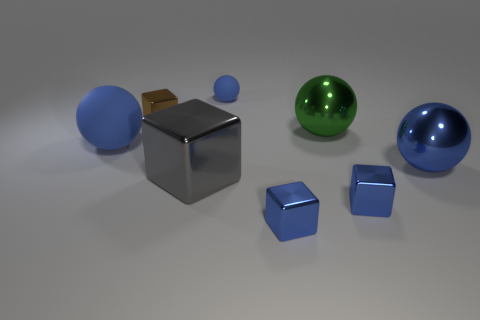There is a metallic thing that is on the left side of the big gray shiny cube; does it have the same shape as the green metallic thing that is in front of the brown thing?
Give a very brief answer. No. What number of objects are small brown metal things or tiny shiny things to the right of the small sphere?
Your answer should be compact. 3. How many other objects are the same size as the brown cube?
Provide a short and direct response. 3. Are the big blue thing that is on the right side of the tiny brown block and the large blue thing left of the small brown shiny object made of the same material?
Your response must be concise. No. What number of large rubber objects are right of the big gray cube?
Provide a short and direct response. 0. How many blue things are either tiny balls or matte objects?
Provide a succinct answer. 2. What material is the green sphere that is the same size as the gray block?
Your answer should be very brief. Metal. What shape is the tiny thing that is both to the right of the brown metallic block and behind the large gray object?
Give a very brief answer. Sphere. What color is the other shiny ball that is the same size as the green shiny ball?
Keep it short and to the point. Blue. Does the blue thing on the left side of the tiny sphere have the same size as the blue matte sphere that is behind the brown cube?
Your answer should be compact. No. 